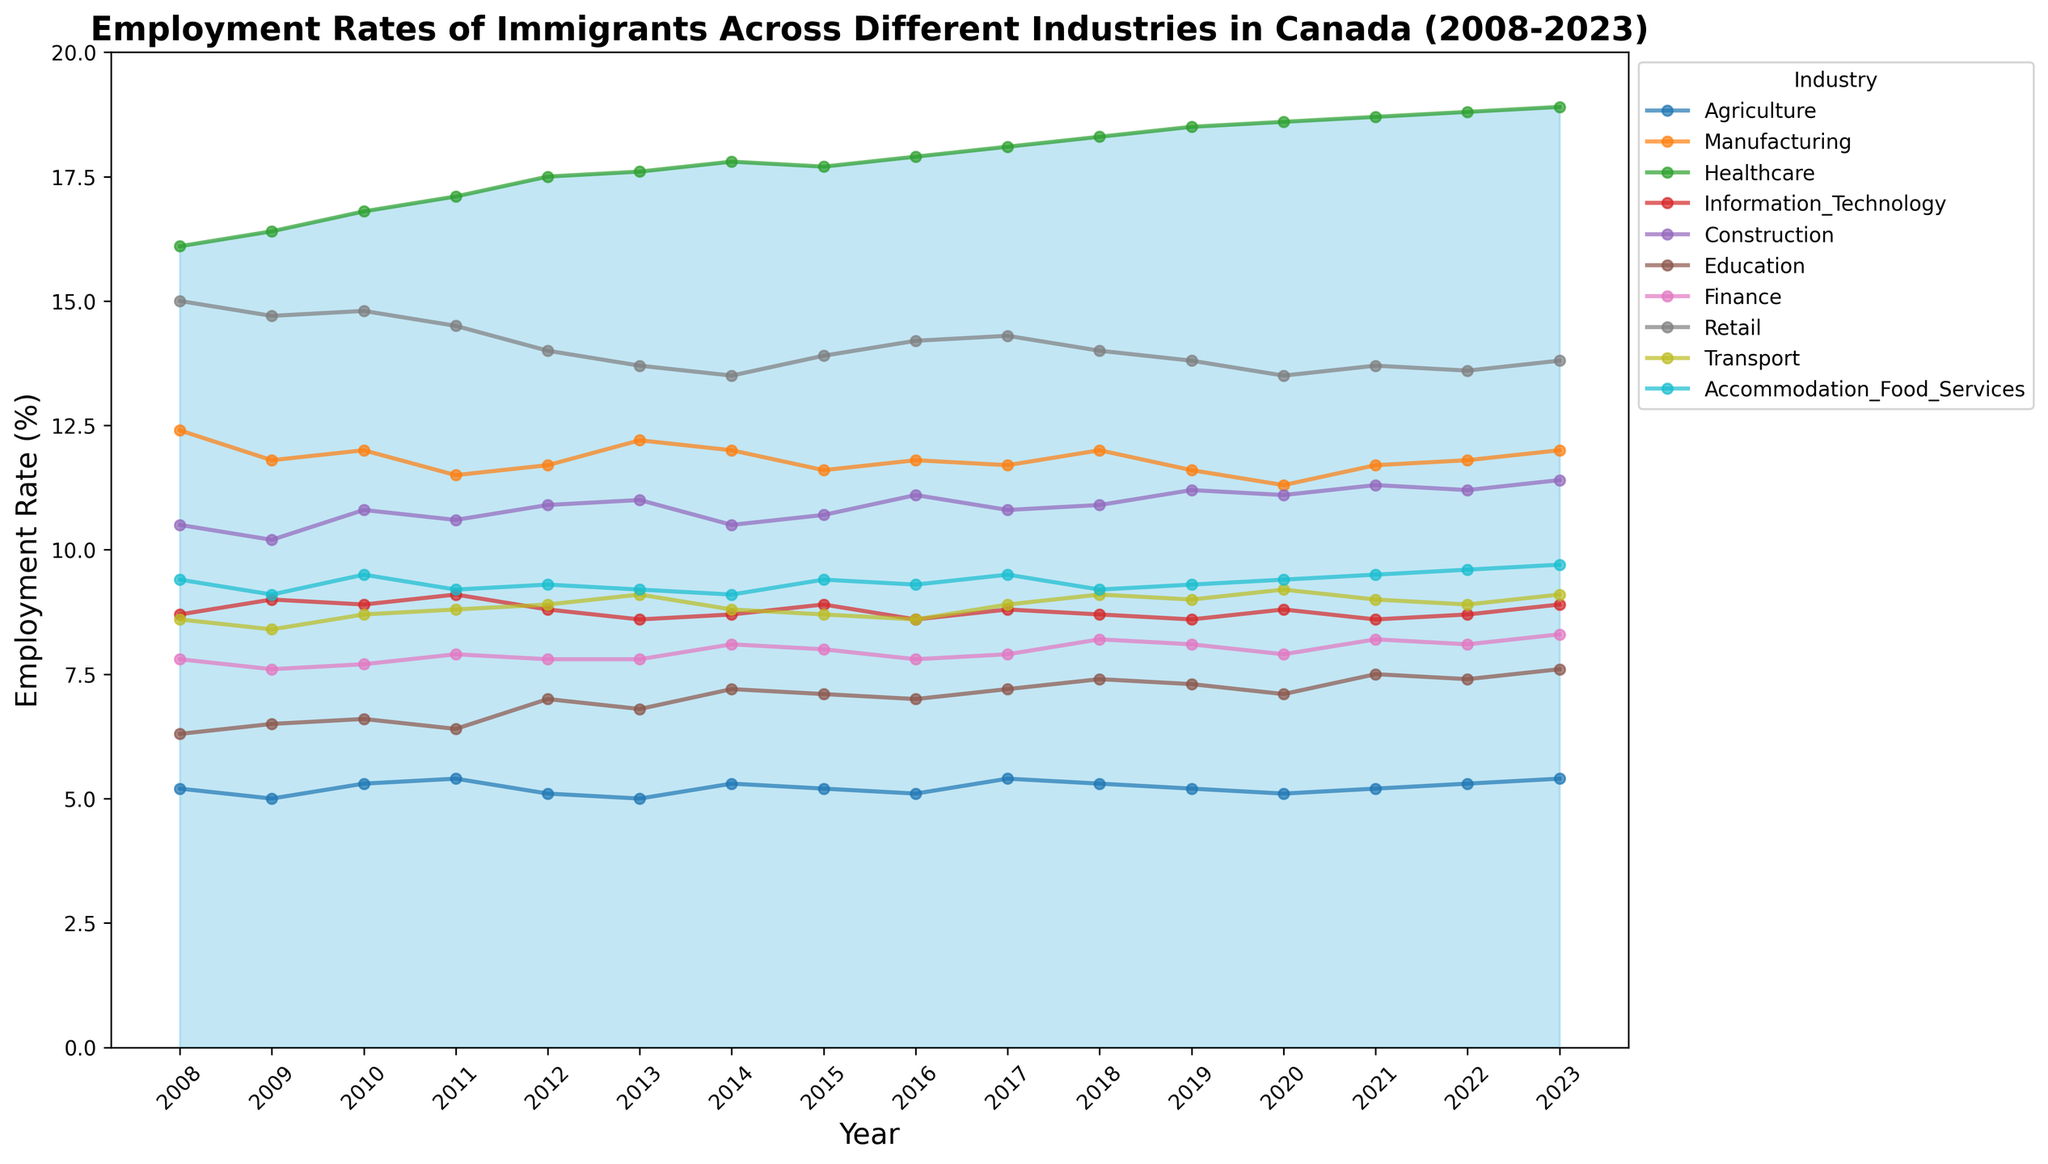What industry has the highest employment rate among immigrants in 2023? The highest employment rate can be observed in the Healthcare industry in 2023 as its peak is clearly above all other industry lines in the plot.
Answer: Healthcare Which industry experienced the largest overall increase in employment rates from 2008 to 2023? By analyzing the lines, Healthcare shows the most considerable increase, starting at 16.1% in 2008 and reaching 18.9% in 2023, visibly the most significant rise.
Answer: Healthcare Compare the employment rates in the Information Technology and Construction industries in 2020. Which one is higher? Identifying and comparing the lines for Information Technology and Construction in 2020 shows that Construction has a slightly higher employment rate (11.1%) than Information Technology (8.8%).
Answer: Construction Has the employment rate in the Agriculture industry seen a steady trend from 2008 to 2023? The Agriculture line generally fluctuates slightly but remains around the 5-5.4% range, showing no drastic changes, suggesting a relatively stable trend.
Answer: Yes Between which years did the employment rate in the Healthcare industry surpass 18%? Observing the Healthcare line, it surpasses 18% starting from 2017 and continues to stay above throughout the observed years till 2023.
Answer: 2017-2023 What is the average employment rate in the Finance industry from 2008 to 2023? Summing up the yearly employment rates in Finance from the data and then dividing by the number of years (16), the average rate can be calculated. (7.8 + 7.6 + 7.7 + 7.9 + 7.8 + 7.8 + 8.1 + 8.0 + 7.8 + 7.9 + 8.2 + 8.1 + 7.9 + 8.2 + 8.1 + 8.3) / 16 =  125.4 / 16 ≈ 7.84
Answer: ≈ 7.84 Which industry showed the least fluctuation in employment rates over the 15 years? By observing the smoothest lines without significant peaks and troughs, Education shows relatively minimal fluctuations, staying mainly between 6 and 7.6%.
Answer: Education In which year did the Accommodation & Food Services industry reach its peak employment rate? The tallest peak for the Accommodation & Food Services line occurs in 2023, where it reaches 9.7%.
Answer: 2023 Did the Manufacturing industry ever surpass a 12% employment rate over the observed period? Yes, the Manufacturing line surpasses 12% in multiple years, including 2008, 2010, 2013, 2014, 2018, and 2023.
Answer: Yes 